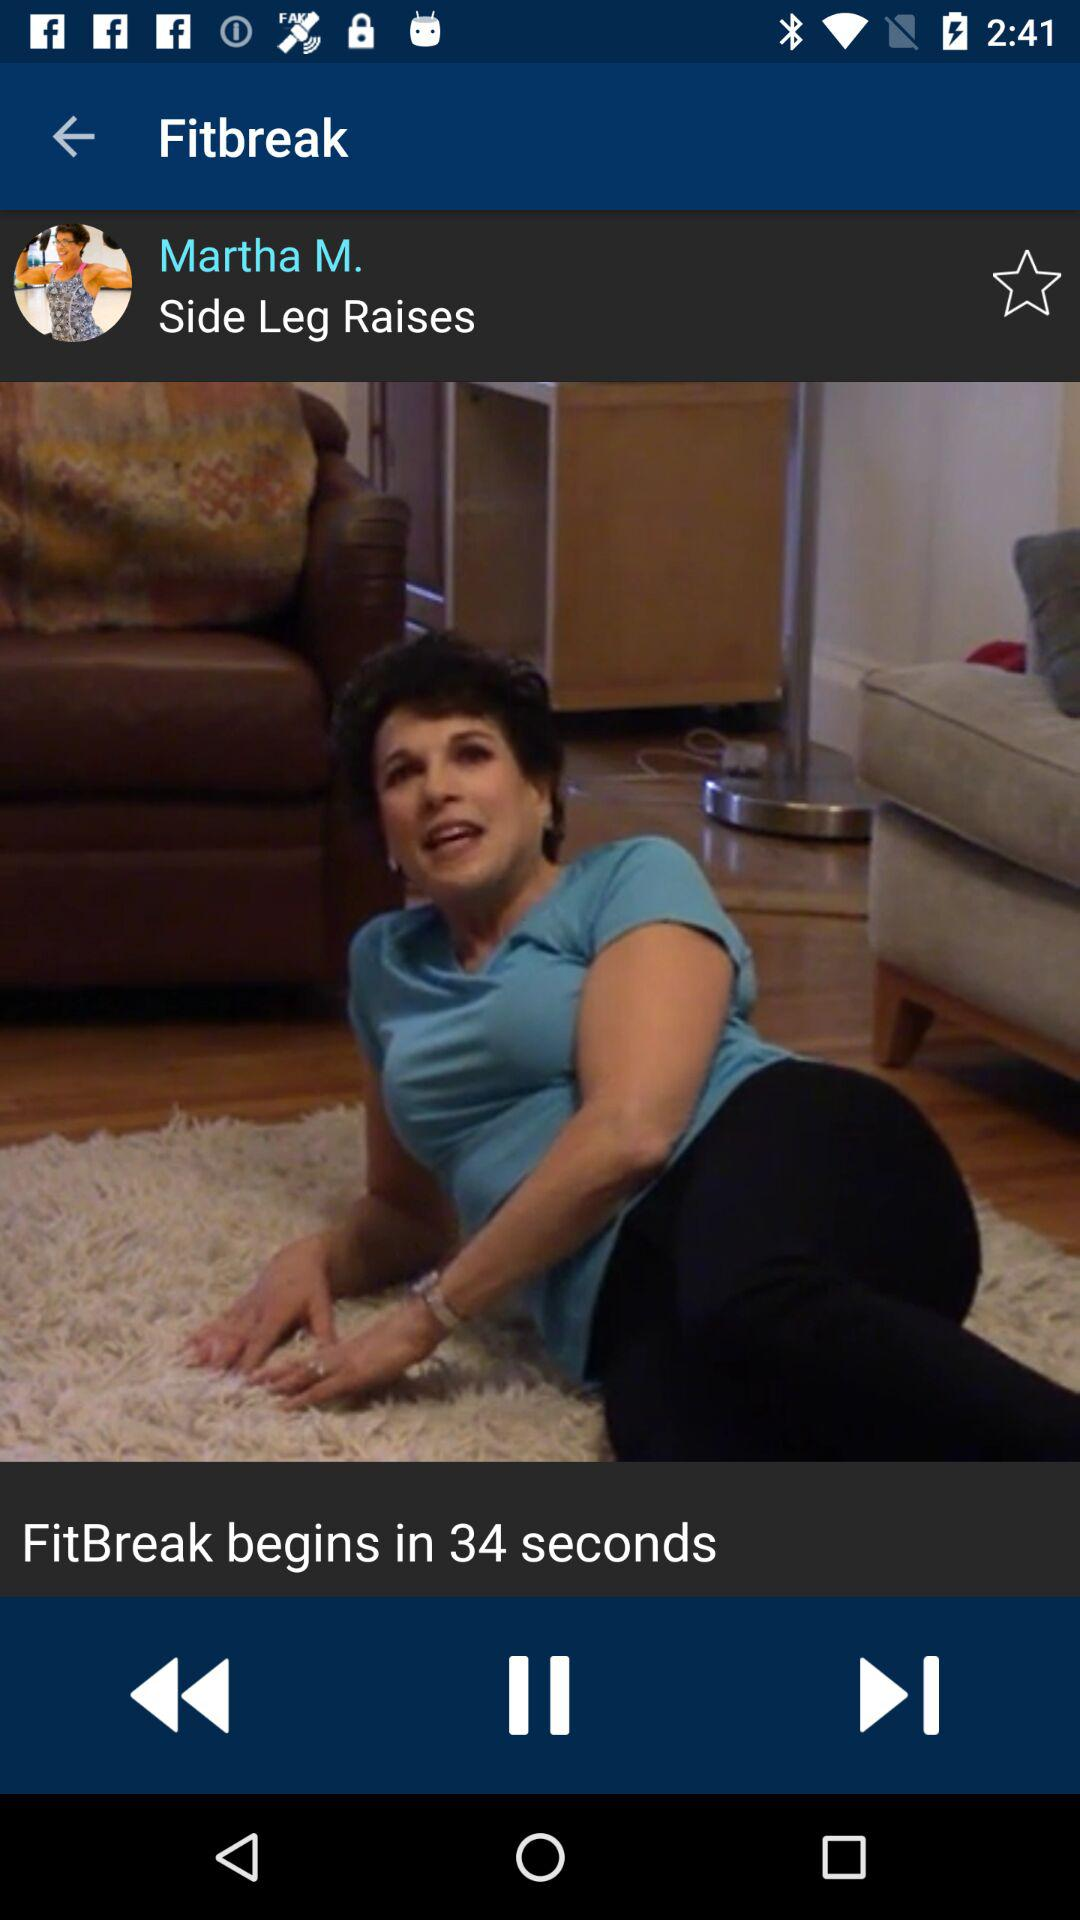What is the application name? The application name is "Fitbreak". 